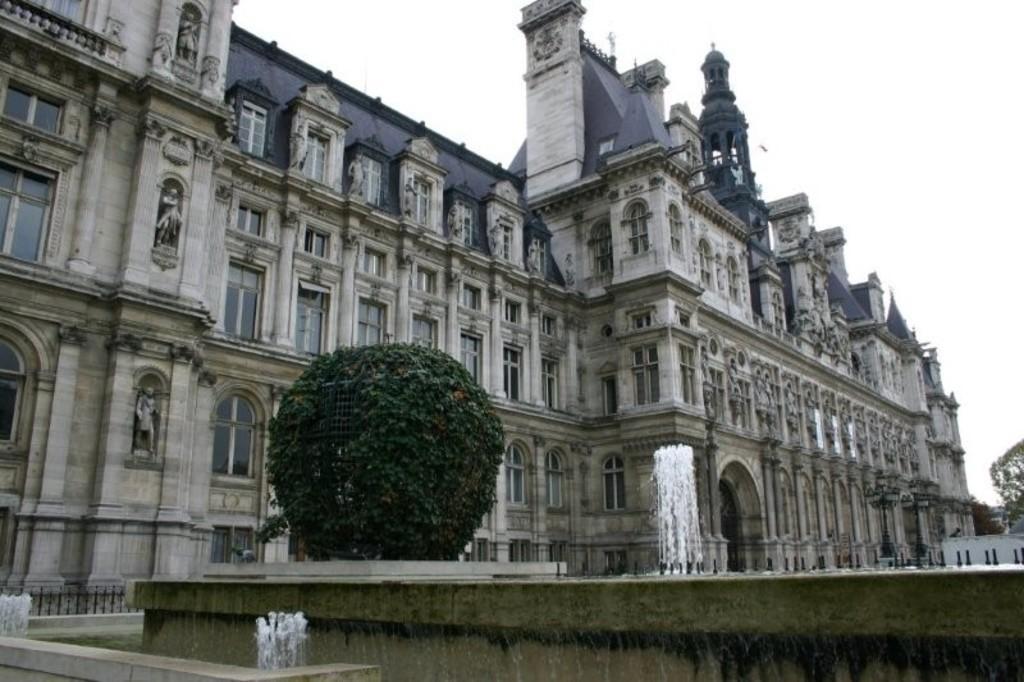In one or two sentences, can you explain what this image depicts? In the background of the image there is a building there is a water fountain. There is a plant. At the top of the image there is sky. 